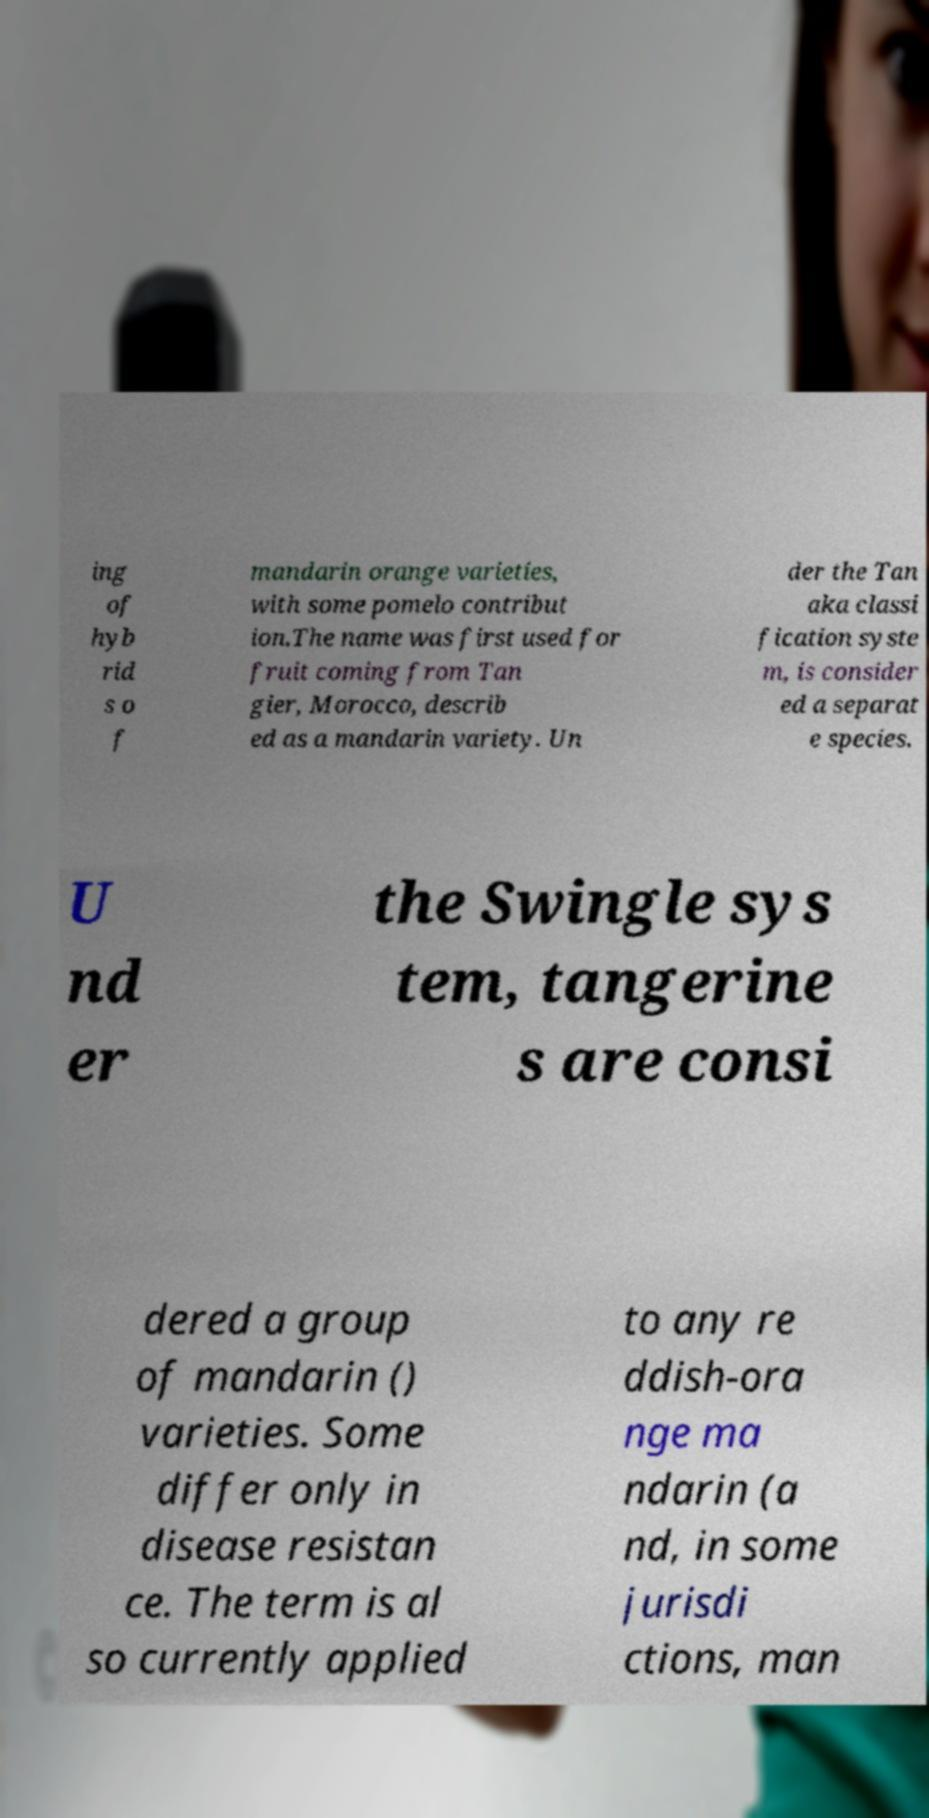Please identify and transcribe the text found in this image. ing of hyb rid s o f mandarin orange varieties, with some pomelo contribut ion.The name was first used for fruit coming from Tan gier, Morocco, describ ed as a mandarin variety. Un der the Tan aka classi fication syste m, is consider ed a separat e species. U nd er the Swingle sys tem, tangerine s are consi dered a group of mandarin () varieties. Some differ only in disease resistan ce. The term is al so currently applied to any re ddish-ora nge ma ndarin (a nd, in some jurisdi ctions, man 